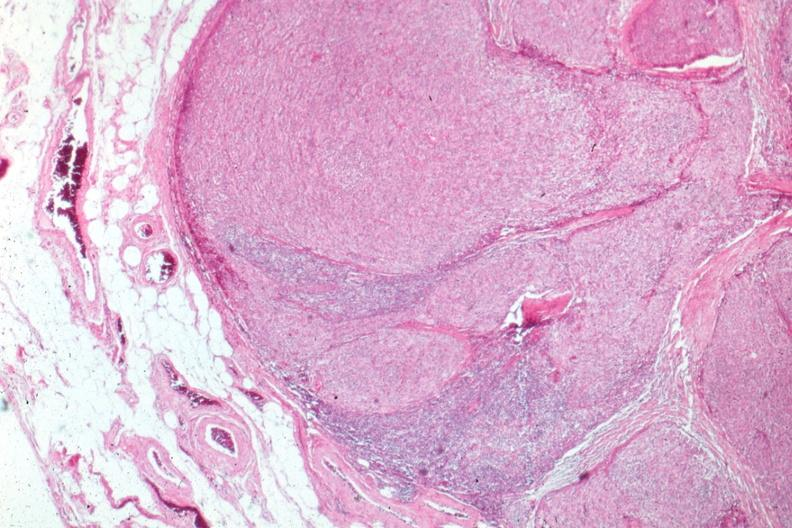what does this image show?
Answer the question using a single word or phrase. Surgical specimen 